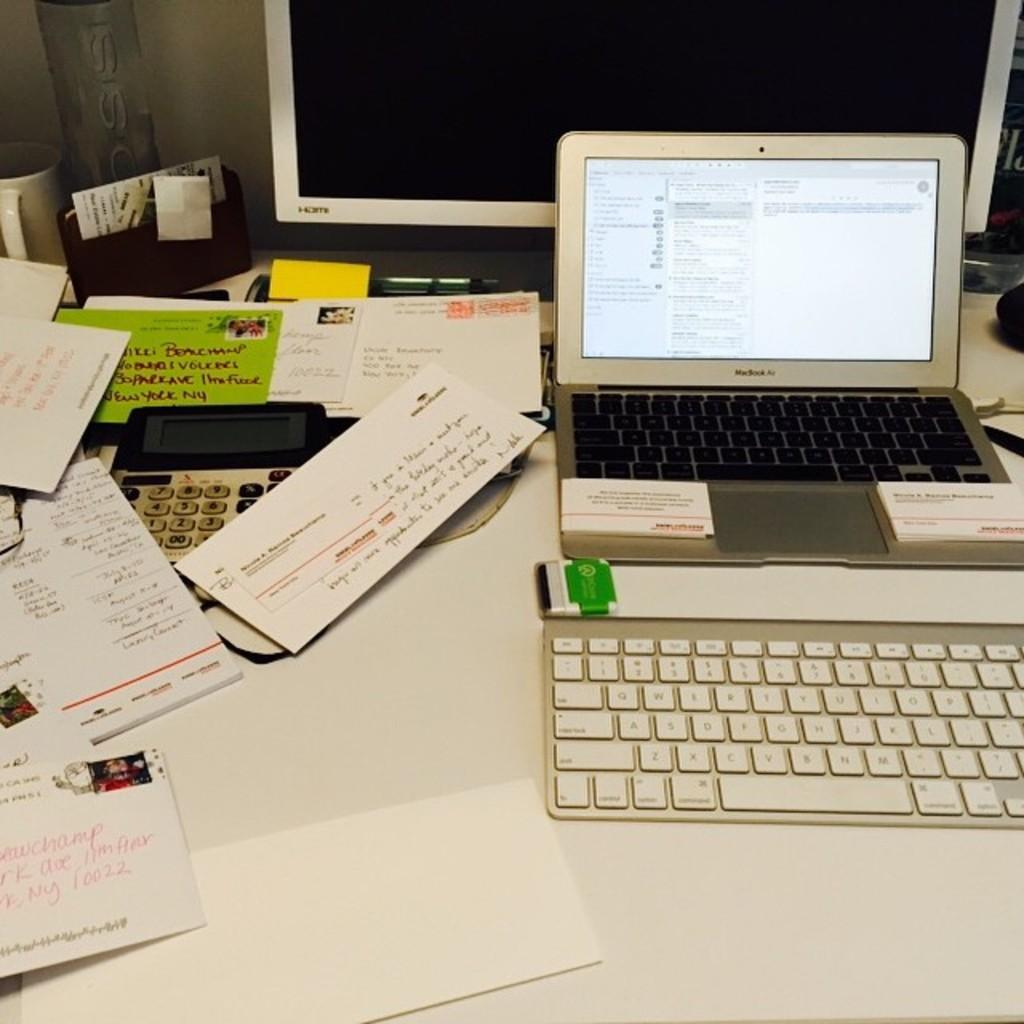What is the main electronic device in the image? There is a big screen in the image. What other electronic device can be seen on the table? There is a laptop in the image. What type of stationery items are present on the table? There are papers in the image. What communication device is visible on the table? There is a telephone in the image. Where are all these objects located? All these objects are on a table. What type of soup is being served in the image? There is no soup present in the image. How long is the person's hair in the image? There is no person or hair visible in the image. 